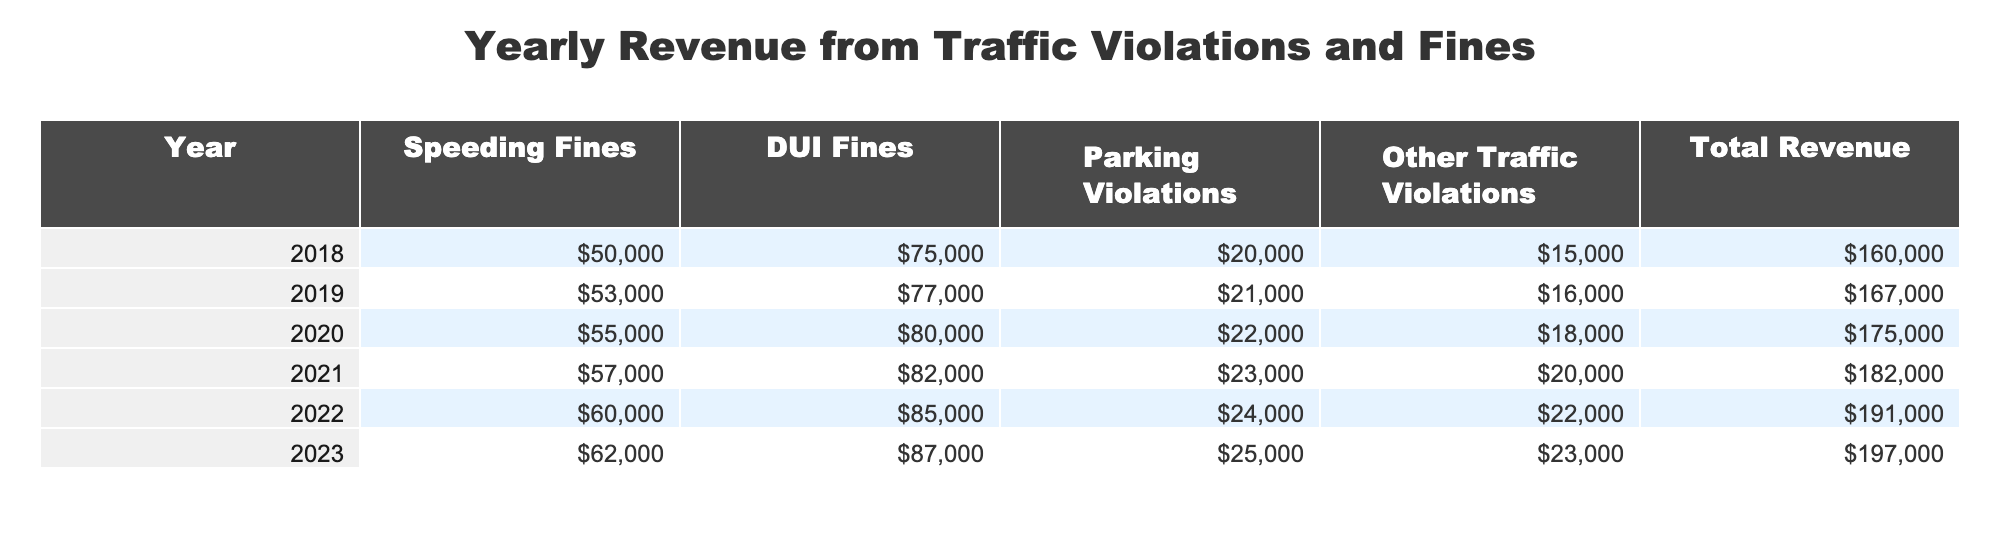What was the total revenue in 2020? The total revenue for the year 2020 is provided in the table under the "Total Revenue" column. For 2020, the value listed is 175000.
Answer: 175000 In which year did the speeding fines exceed 55000 for the first time? By examining the "Speeding Fines" column, I can see that 55000 was first exceeded in the year 2021, where the value is 57000.
Answer: 2021 What is the total amount generated from DUI fines over the years 2018 to 2023? To find the total from DUI fines, I sum up the values from the "DUI Fines" column for each year: 75000 + 77000 + 80000 + 82000 + 85000 + 87000 = 504000.
Answer: 504000 Did the total revenue increase every year from 2018 to 2023? By looking at the "Total Revenue" column, I can see the values for each year are 160000, 167000, 175000, 182000, 191000, and 197000. Each value is greater than the previous year, indicating a consistent increase.
Answer: Yes What was the average revenue generated from parking violations from 2018 to 2023? The parking violation revenues for the years are 20000, 21000, 22000, 23000, 24000, and 25000. Summing these values gives 138000, and dividing by the number of years (6) gives an average of 23000.
Answer: 23000 